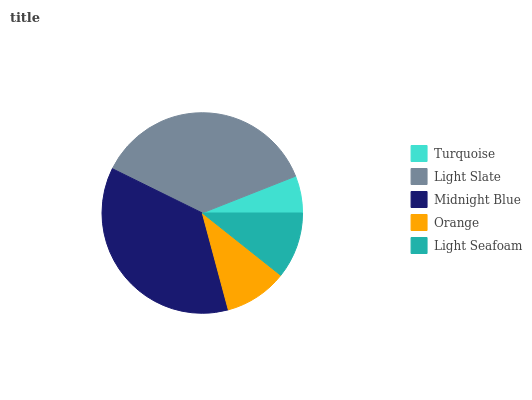Is Turquoise the minimum?
Answer yes or no. Yes. Is Light Slate the maximum?
Answer yes or no. Yes. Is Midnight Blue the minimum?
Answer yes or no. No. Is Midnight Blue the maximum?
Answer yes or no. No. Is Light Slate greater than Midnight Blue?
Answer yes or no. Yes. Is Midnight Blue less than Light Slate?
Answer yes or no. Yes. Is Midnight Blue greater than Light Slate?
Answer yes or no. No. Is Light Slate less than Midnight Blue?
Answer yes or no. No. Is Light Seafoam the high median?
Answer yes or no. Yes. Is Light Seafoam the low median?
Answer yes or no. Yes. Is Orange the high median?
Answer yes or no. No. Is Orange the low median?
Answer yes or no. No. 